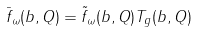<formula> <loc_0><loc_0><loc_500><loc_500>\bar { f } _ { \omega } ( b , Q ) = \tilde { f } _ { \omega } ( b , Q ) T _ { g } ( b , Q )</formula> 